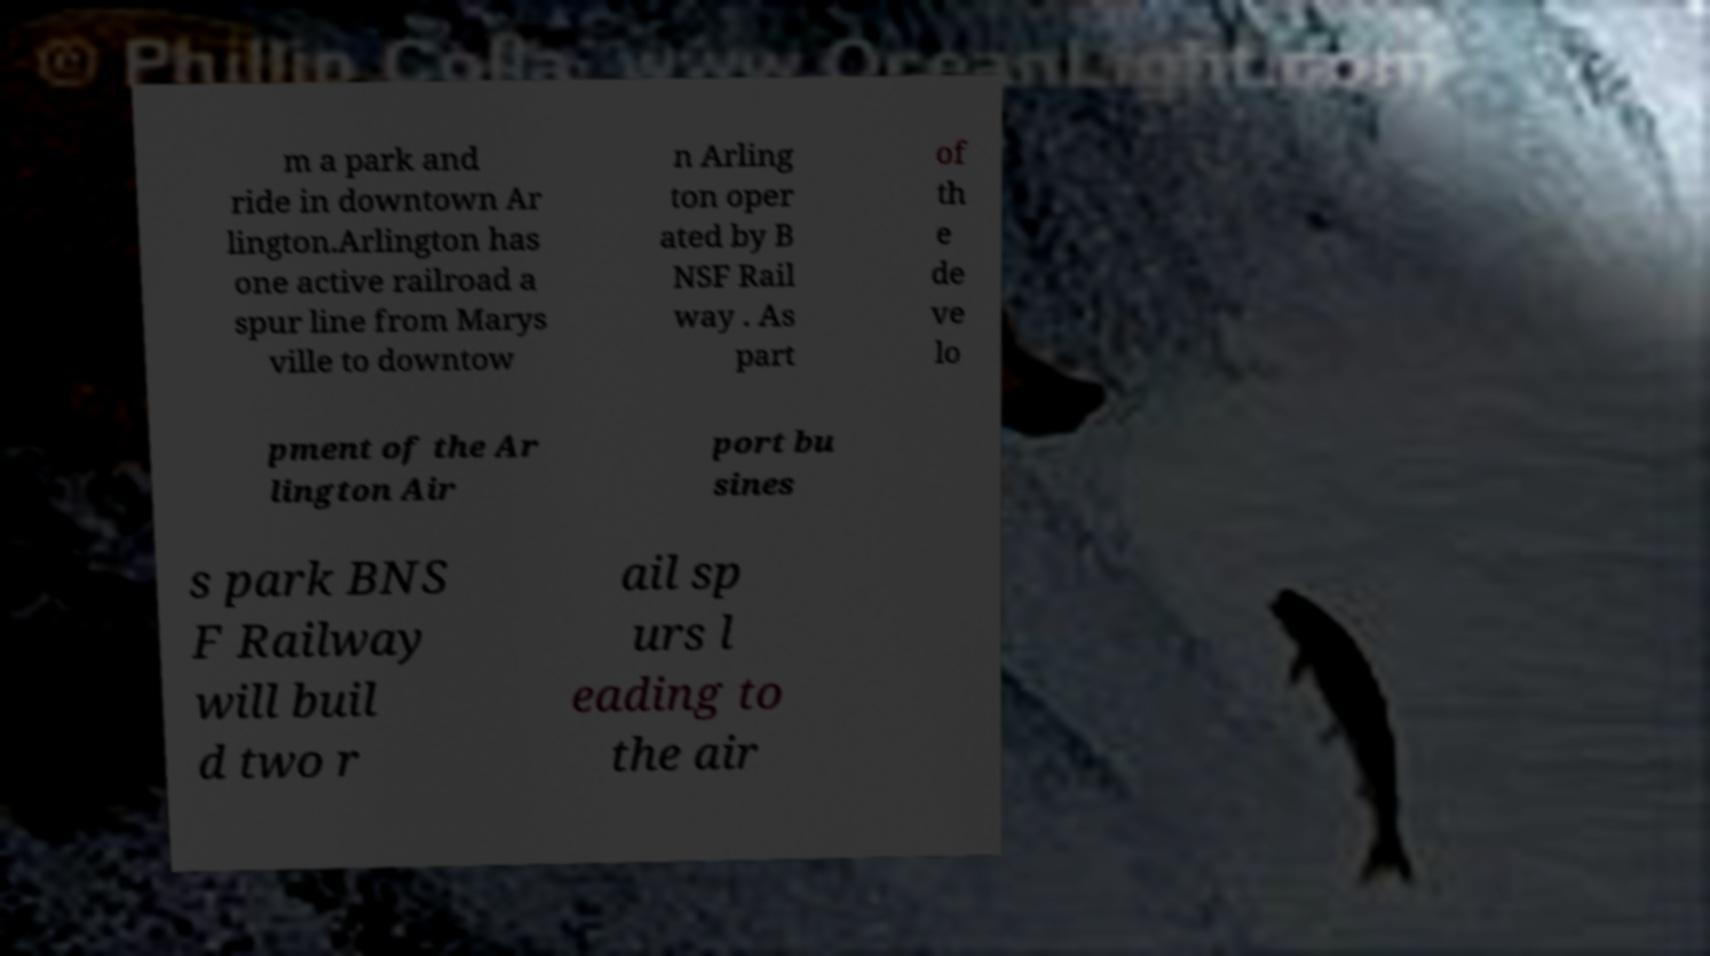Please identify and transcribe the text found in this image. m a park and ride in downtown Ar lington.Arlington has one active railroad a spur line from Marys ville to downtow n Arling ton oper ated by B NSF Rail way . As part of th e de ve lo pment of the Ar lington Air port bu sines s park BNS F Railway will buil d two r ail sp urs l eading to the air 